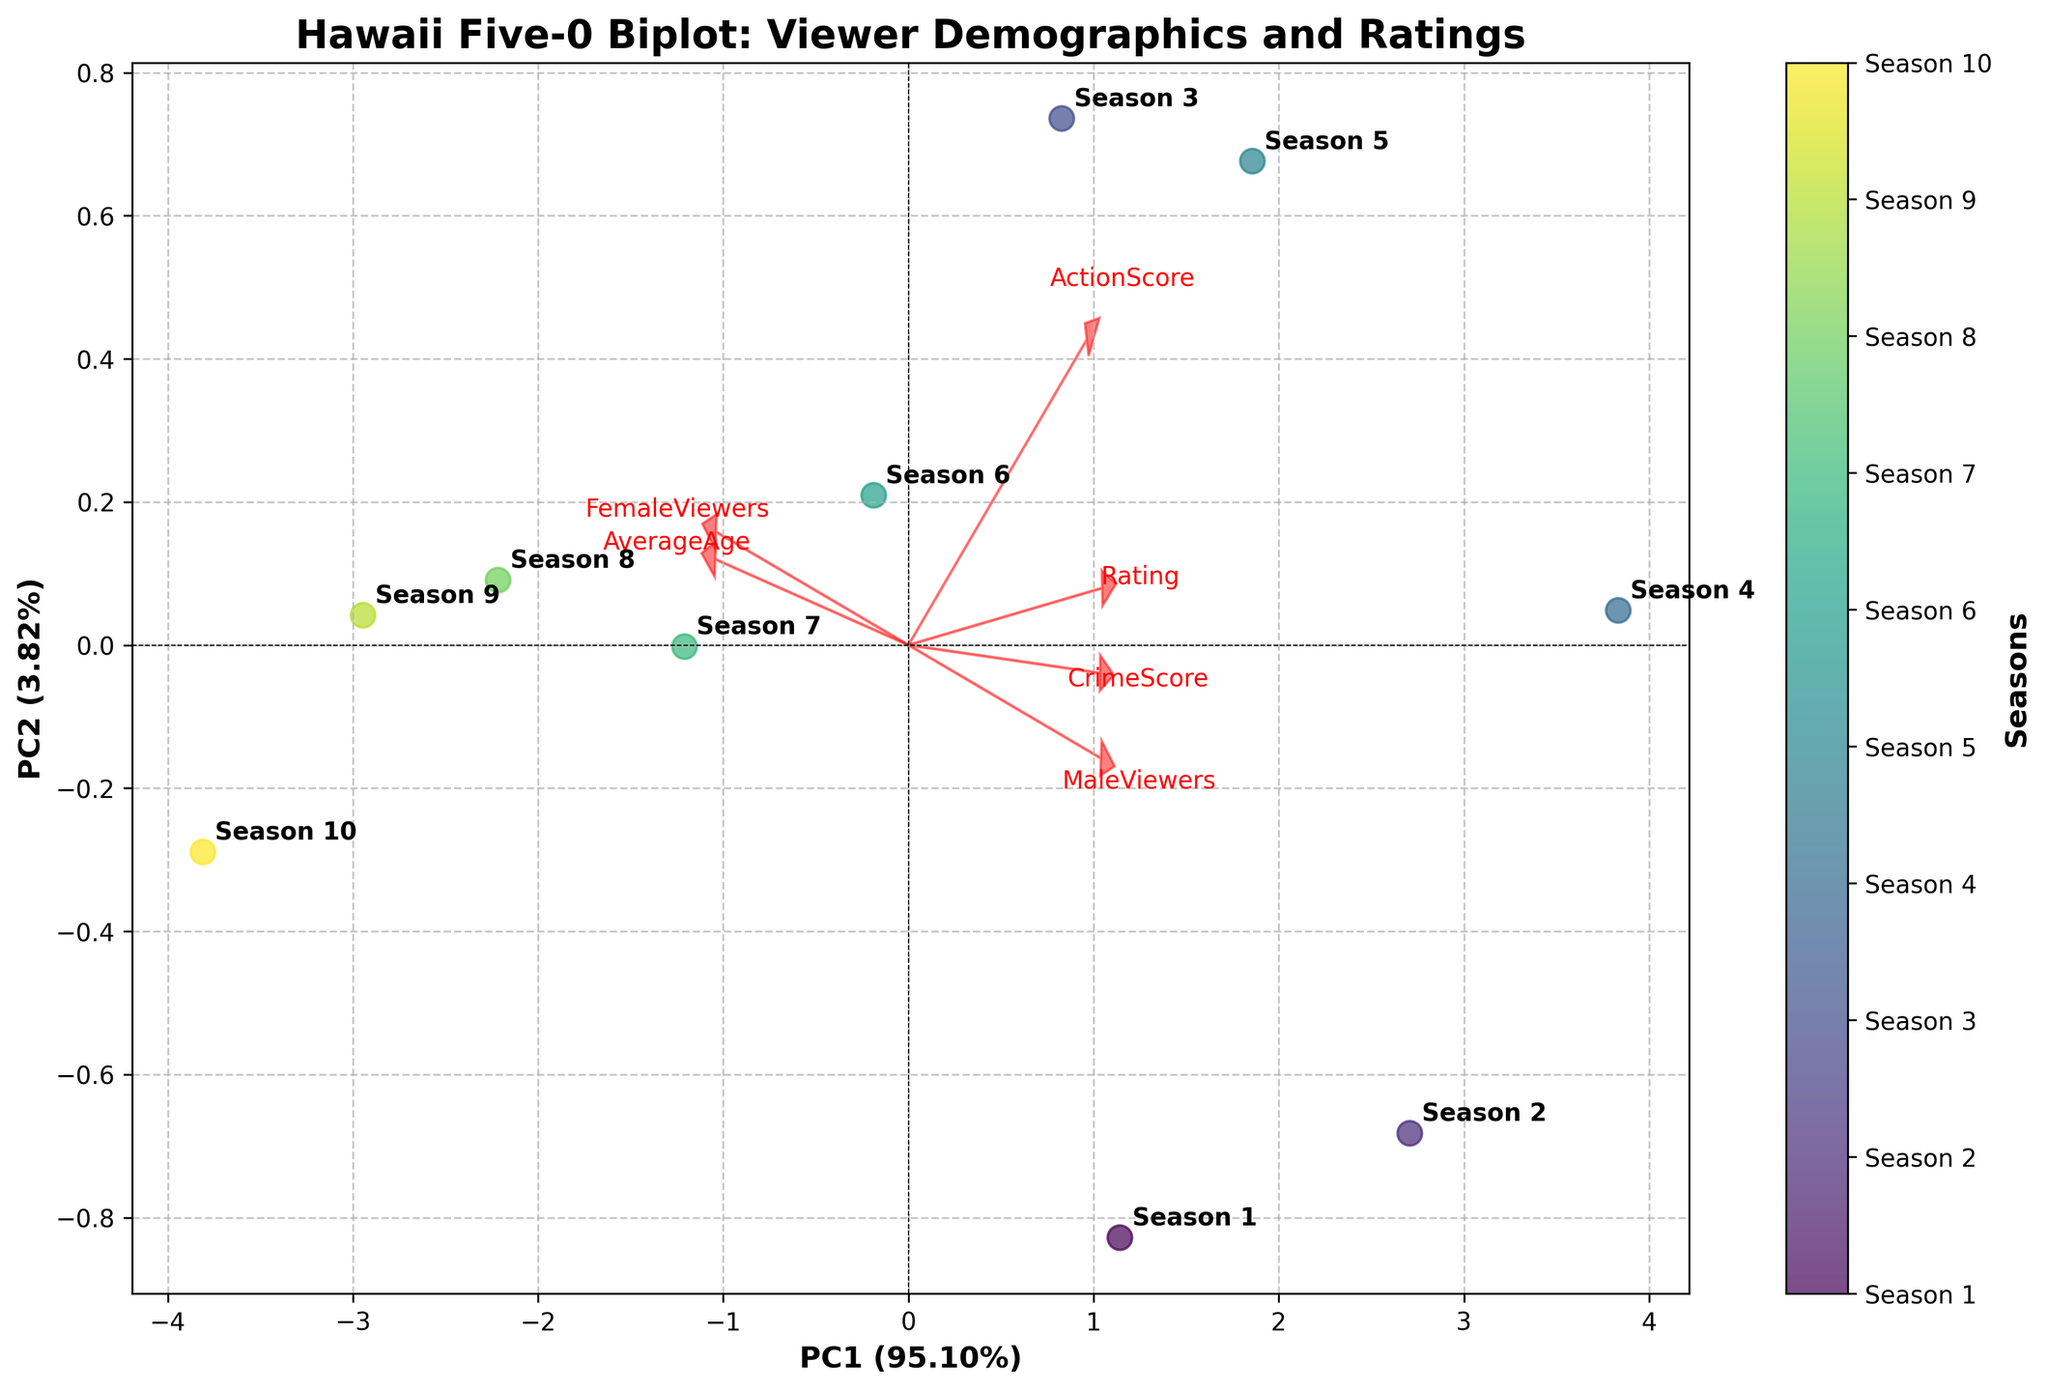What's the title of the figure? The title is displayed prominently at the top of the figure. It is bold and large.
Answer: Hawaii Five-0 Biplot: Viewer Demographics and Ratings What does PC1 represent in terms of explained variance ratio? The explained variance ratio for PC1 is shown in the label of the x-axis.
Answer: Approximately 28% Which season has the highest Rating value according to the biplot? The seasons are annotated near the data points in the biplot, and the PC score scatter shows their positions. The highest Rating values should be checked against the file data, which matches Season 4 near the highest PC1 value corresponding to higher Rating.
Answer: Season 4 Where is the FemaleViewers vector pointing in the plot? The vectors are color-coded red, with each one labeled with its respective feature. The FemaleViewers vector's direction and length indicate its influence on the data points in the PC space.
Answer: Towards the top-right Compare the directions of MaleViewers and FemaleViewers vectors. Find the vectors labeled MaleViewers and FemaleViewers. Observe their directions by following the arrows.
Answer: They point in nearly opposite directions Which seasons seem to have similar demographics? Seasons with similar demographics will cluster closely together in the plot as their PC scores are similar.
Answer: Seasons 9 and 10 Is ActionScore more strongly associated with PC1 or PC2? Analyze the length and direction of the ActionScore vector in relation to the PC1 and PC2 axes. The stronger association will be in the axis it points more towards.
Answer: PC1 Which feature contributes most to PC2 according to the loadings? Check which vector aligns most closely with the PC2 axis.
Answer: AverageAge Explain how viewers' ages and gender are related in this biplot. Look at the vectors for AverageAge, MaleViewers, and FemaleViewers. Compare their directions and proximities to infer relationships. If they point in similar or opposite directions, it shows positive or negative correlations, respectively.
Answer: Younger viewers are more likely to be males Which feature pairwise correlations can be visually inferred from the biplot? Examine the angles between vectors: smaller angles indicate positive correlations, larger angles (up to 180 degrees) indicate negative correlations.
Answer: MaleViewers and AverageAge are negatively correlated 